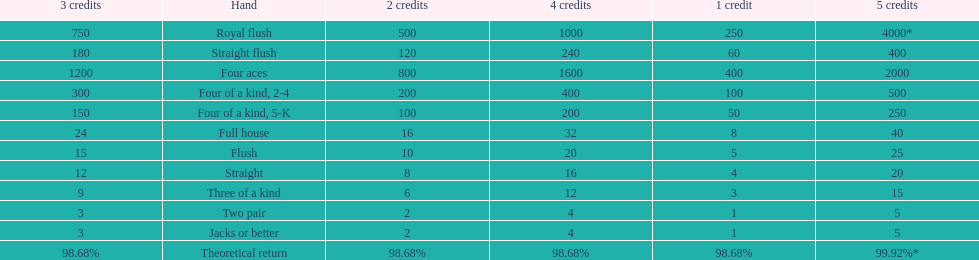After winning on four credits with a full house, what is your payout? 32. 